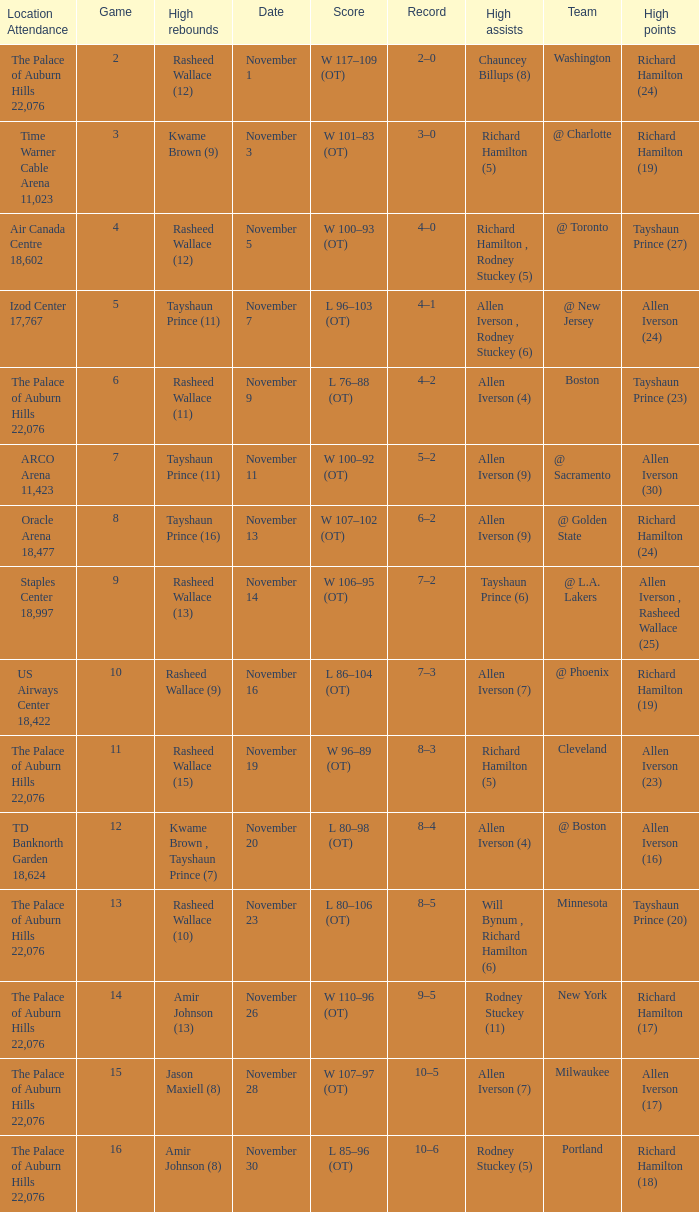What is the average Game, when Team is "Milwaukee"? 15.0. 